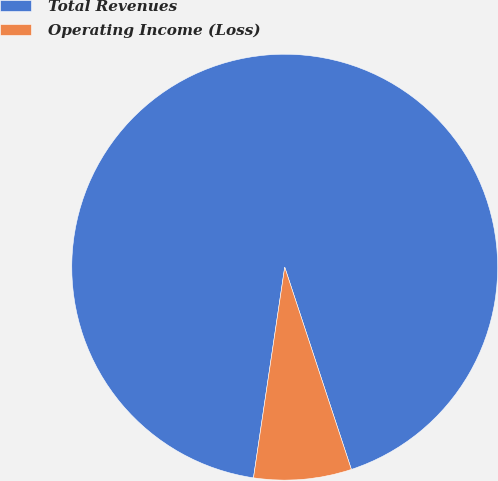<chart> <loc_0><loc_0><loc_500><loc_500><pie_chart><fcel>Total Revenues<fcel>Operating Income (Loss)<nl><fcel>92.59%<fcel>7.41%<nl></chart> 